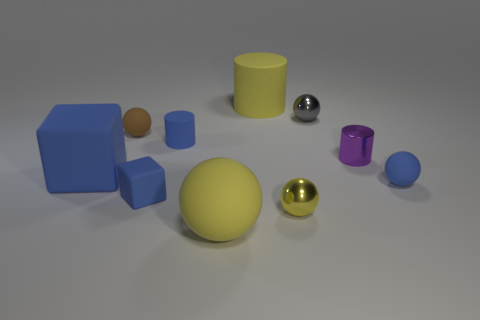There is a rubber sphere that is on the right side of the gray object; is its size the same as the big blue block? No, the rubber sphere on the right side of the gray object is smaller in diameter compared to the dimensions of the large blue block, which has a larger volume. 